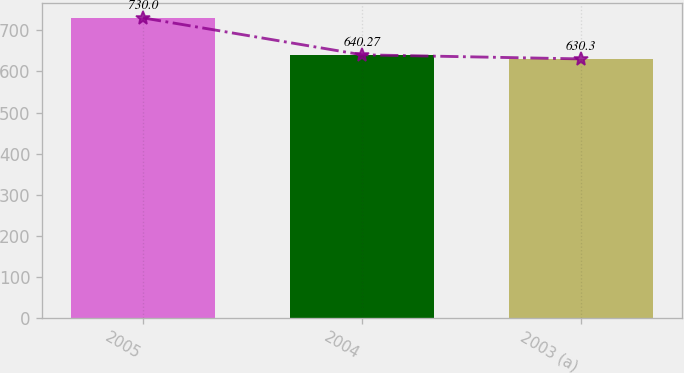<chart> <loc_0><loc_0><loc_500><loc_500><bar_chart><fcel>2005<fcel>2004<fcel>2003 (a)<nl><fcel>730<fcel>640.27<fcel>630.3<nl></chart> 